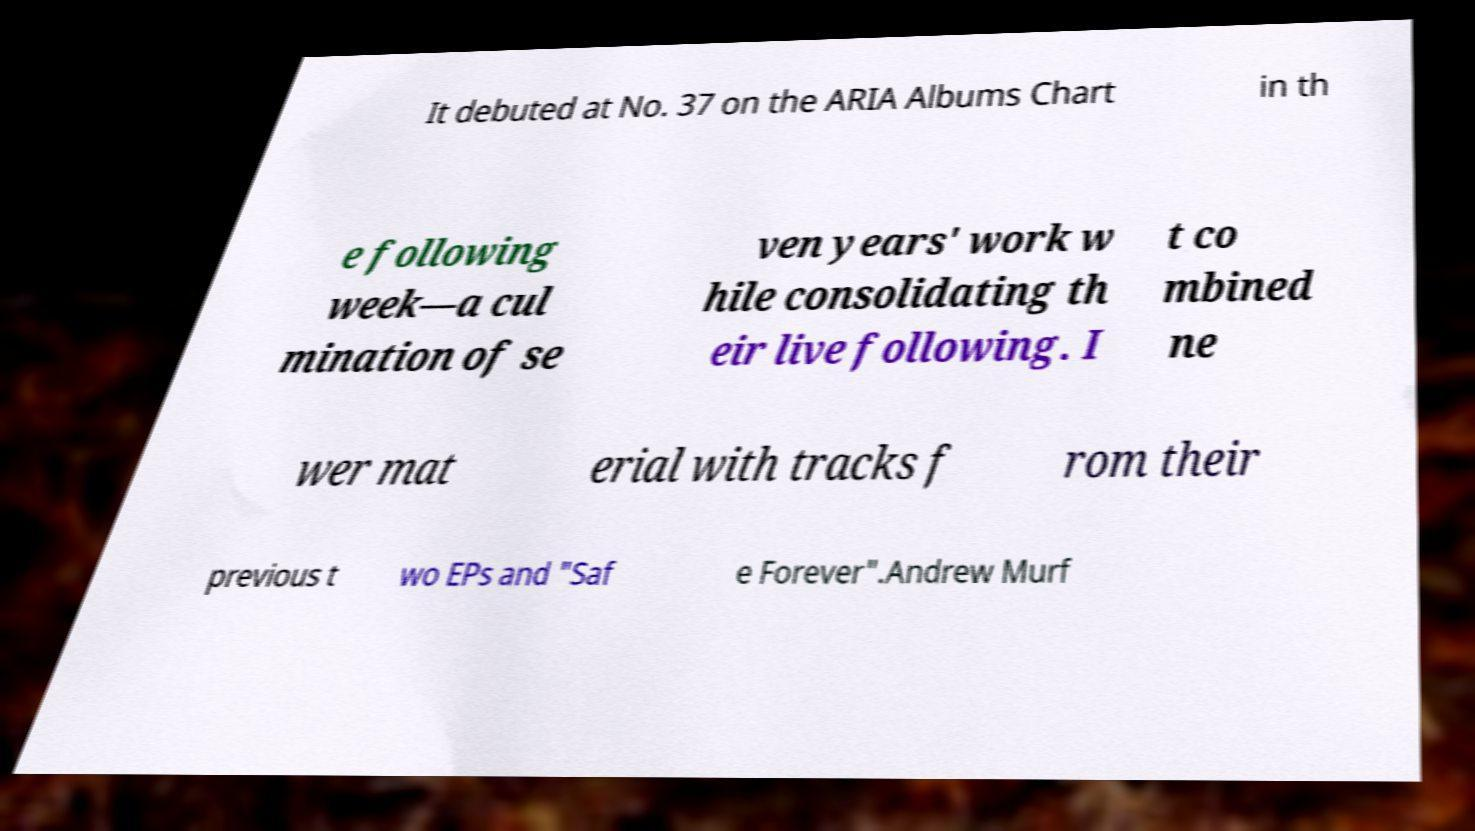There's text embedded in this image that I need extracted. Can you transcribe it verbatim? It debuted at No. 37 on the ARIA Albums Chart in th e following week—a cul mination of se ven years' work w hile consolidating th eir live following. I t co mbined ne wer mat erial with tracks f rom their previous t wo EPs and "Saf e Forever".Andrew Murf 